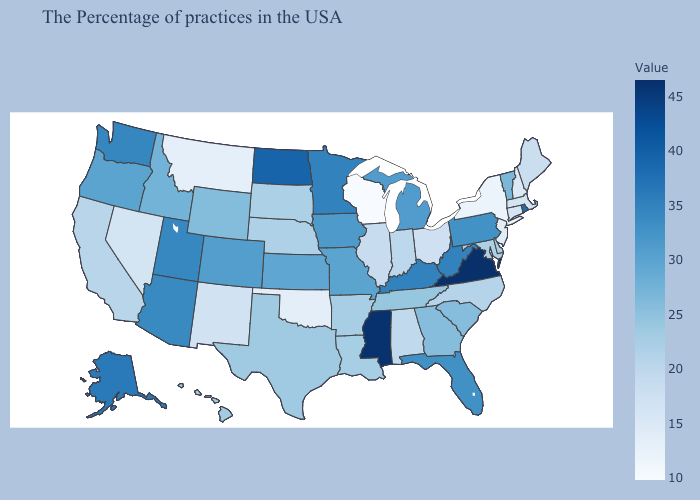Does New Jersey have the lowest value in the Northeast?
Give a very brief answer. No. Which states have the lowest value in the USA?
Concise answer only. Wisconsin. Among the states that border Wyoming , does Nebraska have the lowest value?
Keep it brief. No. Which states have the highest value in the USA?
Keep it brief. Virginia. Among the states that border New Hampshire , does Massachusetts have the lowest value?
Give a very brief answer. Yes. Among the states that border Louisiana , which have the highest value?
Quick response, please. Mississippi. 